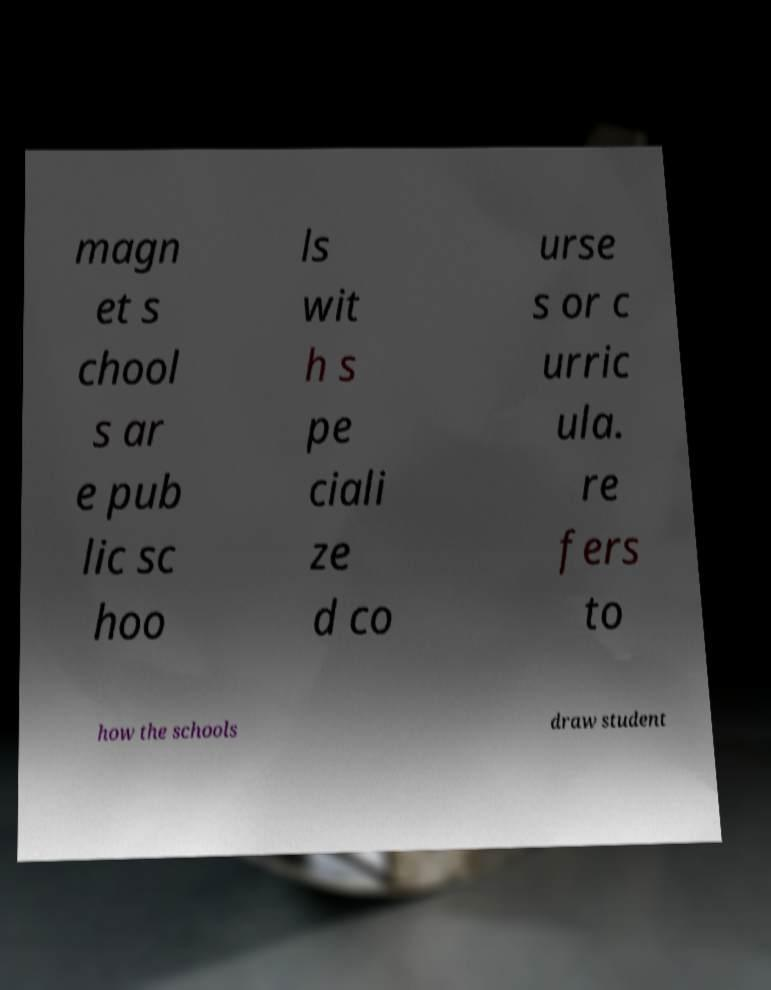Can you accurately transcribe the text from the provided image for me? magn et s chool s ar e pub lic sc hoo ls wit h s pe ciali ze d co urse s or c urric ula. re fers to how the schools draw student 